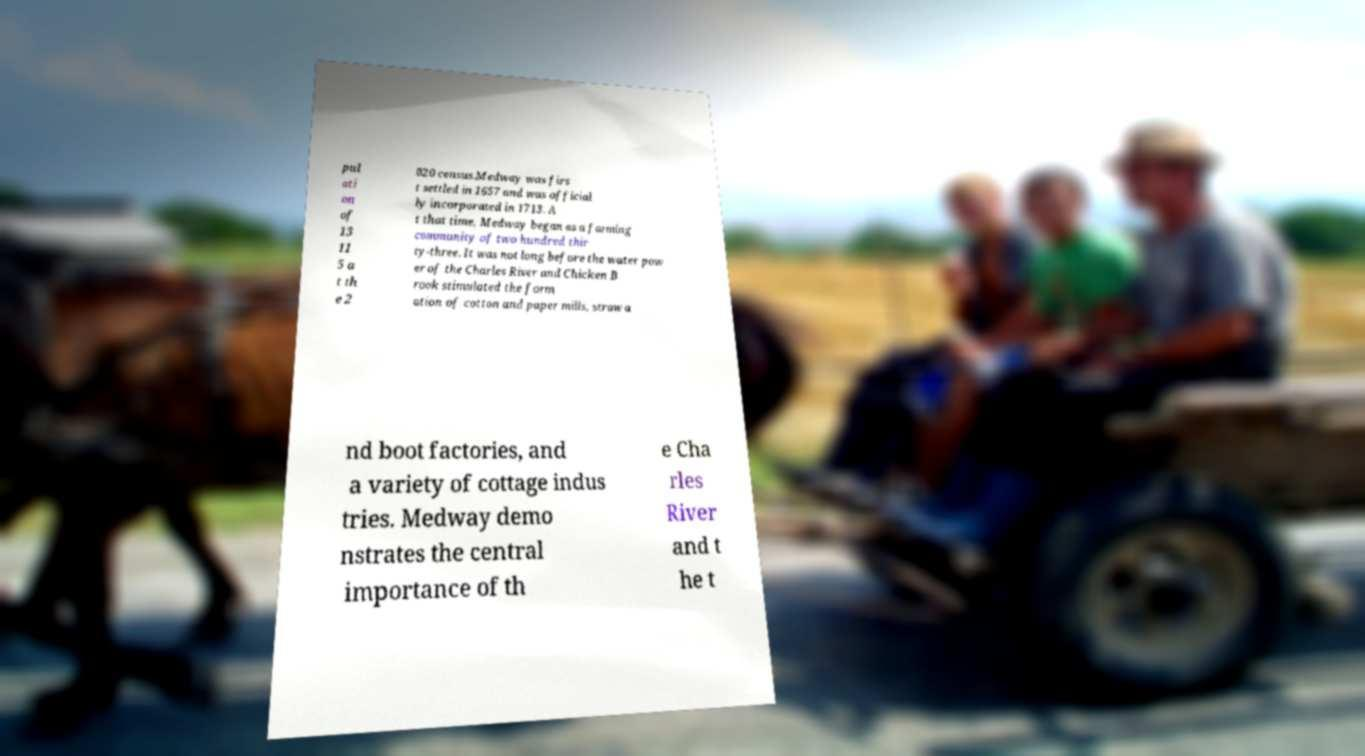Can you accurately transcribe the text from the provided image for me? pul ati on of 13 11 5 a t th e 2 020 census.Medway was firs t settled in 1657 and was official ly incorporated in 1713. A t that time, Medway began as a farming community of two hundred thir ty-three. It was not long before the water pow er of the Charles River and Chicken B rook stimulated the form ation of cotton and paper mills, straw a nd boot factories, and a variety of cottage indus tries. Medway demo nstrates the central importance of th e Cha rles River and t he t 